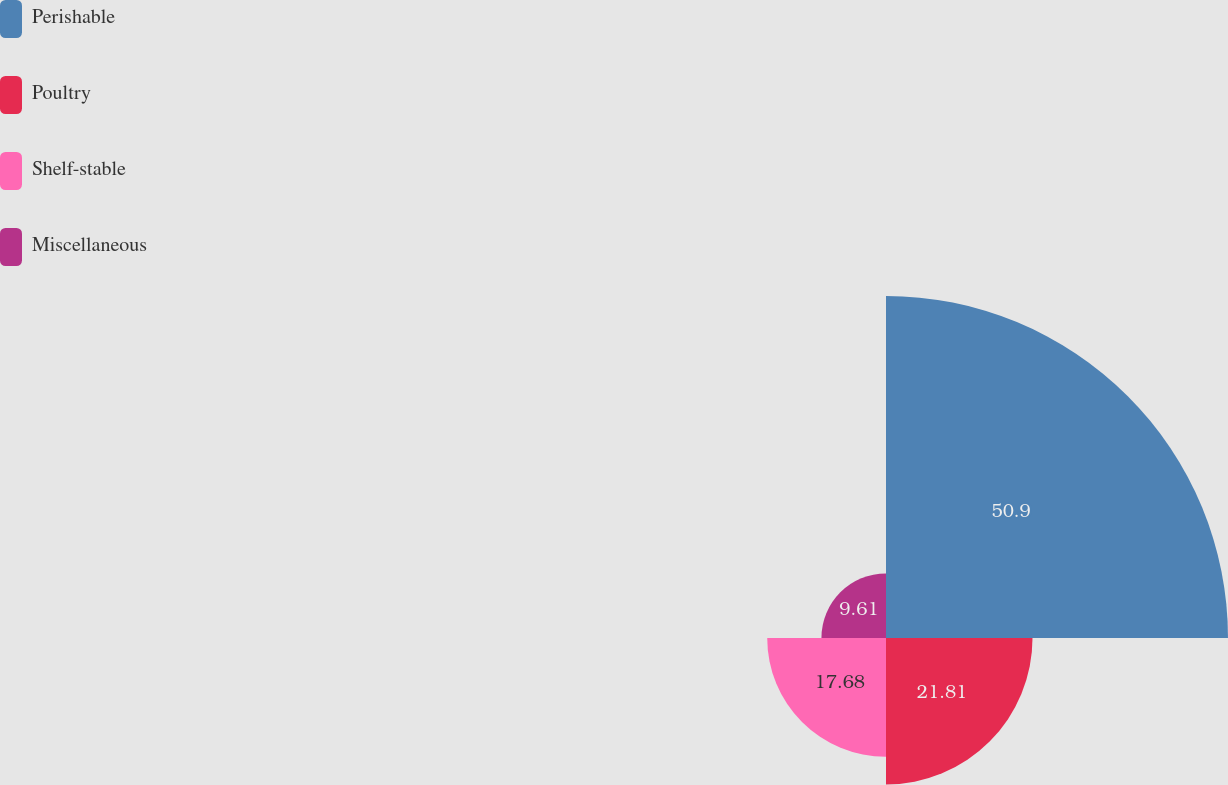Convert chart. <chart><loc_0><loc_0><loc_500><loc_500><pie_chart><fcel>Perishable<fcel>Poultry<fcel>Shelf-stable<fcel>Miscellaneous<nl><fcel>50.91%<fcel>21.81%<fcel>17.68%<fcel>9.61%<nl></chart> 